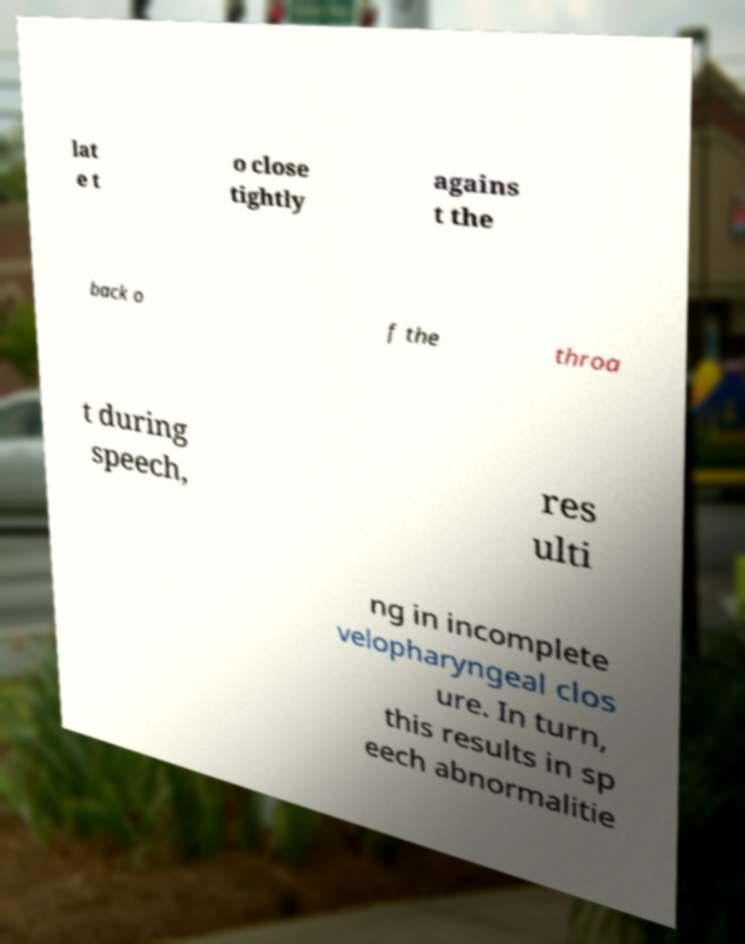There's text embedded in this image that I need extracted. Can you transcribe it verbatim? lat e t o close tightly agains t the back o f the throa t during speech, res ulti ng in incomplete velopharyngeal clos ure. In turn, this results in sp eech abnormalitie 